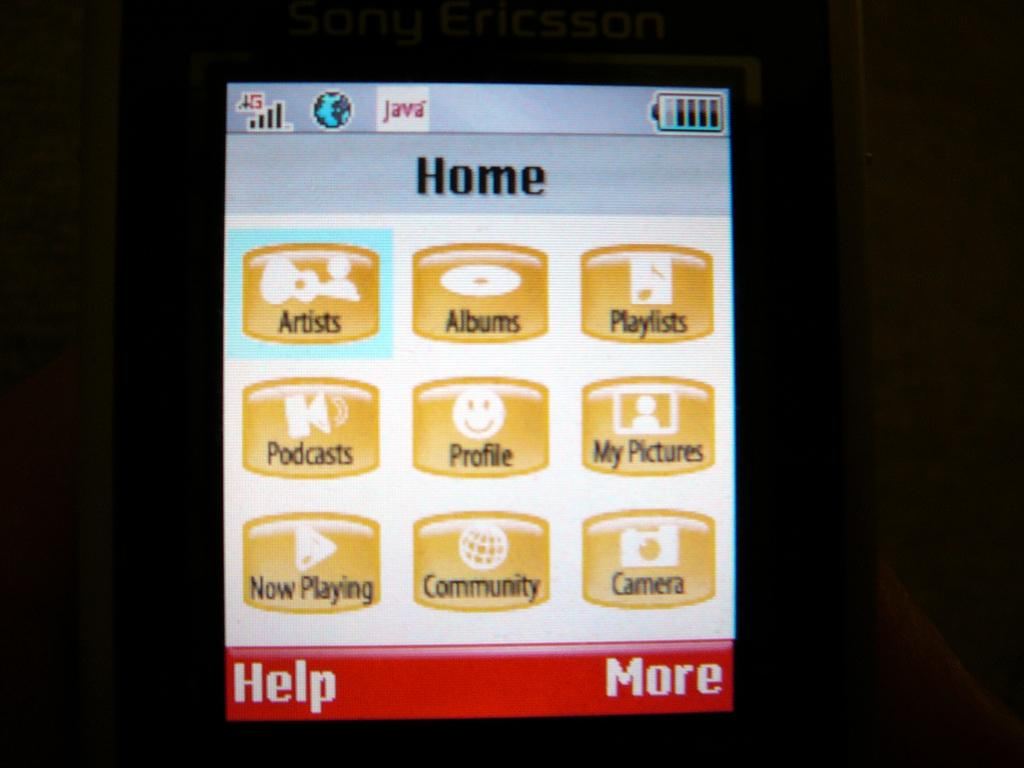<image>
Write a terse but informative summary of the picture. A  screen showing icons such as "Albums" and "Playlists". 